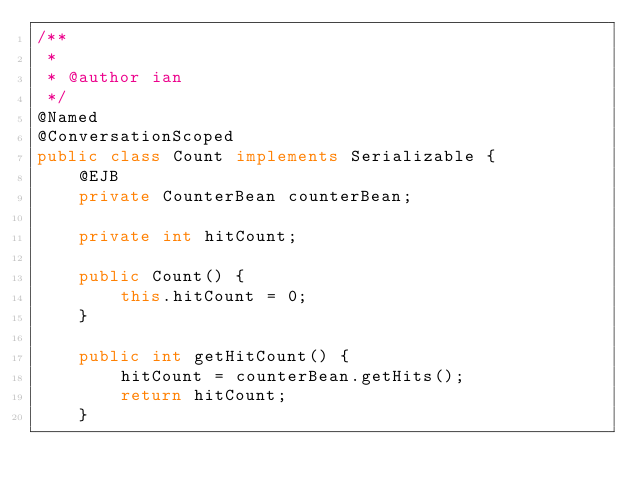<code> <loc_0><loc_0><loc_500><loc_500><_Java_>/**
 *
 * @author ian
 */
@Named
@ConversationScoped
public class Count implements Serializable {
    @EJB
    private CounterBean counterBean;

    private int hitCount;

    public Count() {
        this.hitCount = 0;
    }

    public int getHitCount() {
        hitCount = counterBean.getHits();
        return hitCount;
    }
</code> 